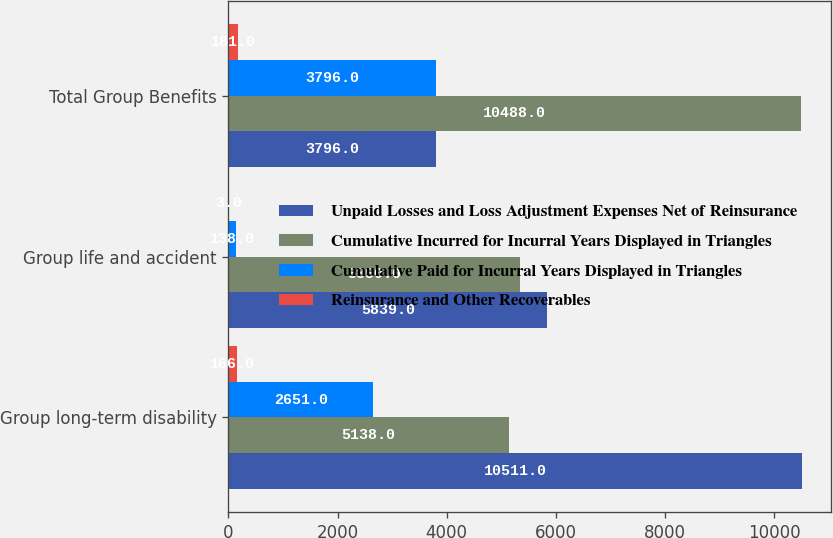<chart> <loc_0><loc_0><loc_500><loc_500><stacked_bar_chart><ecel><fcel>Group long-term disability<fcel>Group life and accident<fcel>Total Group Benefits<nl><fcel>Unpaid Losses and Loss Adjustment Expenses Net of Reinsurance<fcel>10511<fcel>5839<fcel>3796<nl><fcel>Cumulative Incurred for Incurral Years Displayed in Triangles<fcel>5138<fcel>5350<fcel>10488<nl><fcel>Cumulative Paid for Incurral Years Displayed in Triangles<fcel>2651<fcel>138<fcel>3796<nl><fcel>Reinsurance and Other Recoverables<fcel>166<fcel>3<fcel>181<nl></chart> 